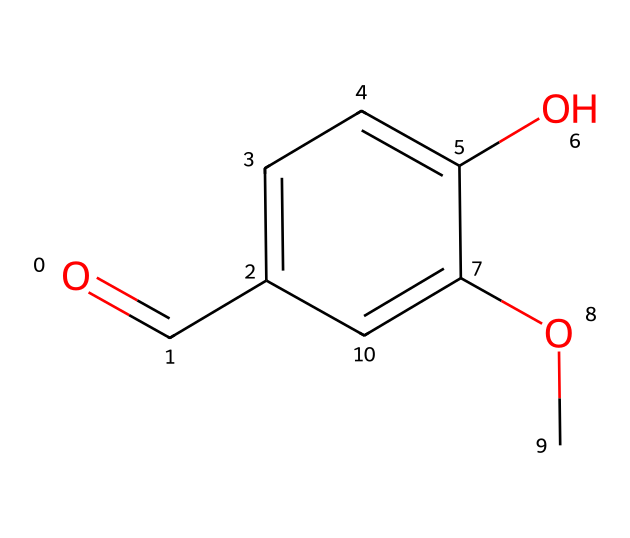What is the functional group present in this chemical? The chemical structure features a carbonyl group, which is indicated by the O=C part. This is characteristic of aldehydes.
Answer: aldehyde How many hydroxyl groups are present in this chemical? In the structure, the -OH group is represented at one position on the aromatic ring, indicating a single hydroxyl group is present.
Answer: one What type of chemical compound is represented by this structure? The presence of an aldehyde functional group along with the aromatic ring classifies this compound as a phenolic aldehyde.
Answer: phenolic aldehyde How many carbon atoms are there in the structure? By counting the carbon atoms in the molecular structure, there are a total of eight carbon atoms present.
Answer: eight What is the role of the methoxy group in this structure? The methoxy group (–OCH3) contributes to the overall aroma and solubility properties of vanillin, enhancing its scent profile.
Answer: aroma enhancement How many double bonds are present in this chemical's structure? The structure features one double bond in the carbonyl group (C=O) and no other double bonds in the remaining carbon chain.
Answer: one Does this compound exhibit acidity? Due to the presence of the hydroxyl group, which can donate a hydrogen ion, this compound can exhibit weak acidity.
Answer: weak acidity 